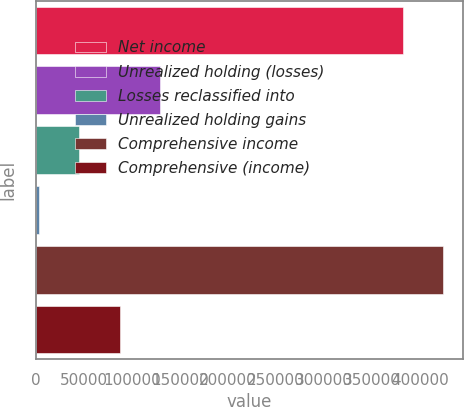<chart> <loc_0><loc_0><loc_500><loc_500><bar_chart><fcel>Net income<fcel>Unrealized holding (losses)<fcel>Losses reclassified into<fcel>Unrealized holding gains<fcel>Comprehensive income<fcel>Comprehensive (income)<nl><fcel>382029<fcel>129254<fcel>45467.5<fcel>3574<fcel>423922<fcel>87361<nl></chart> 